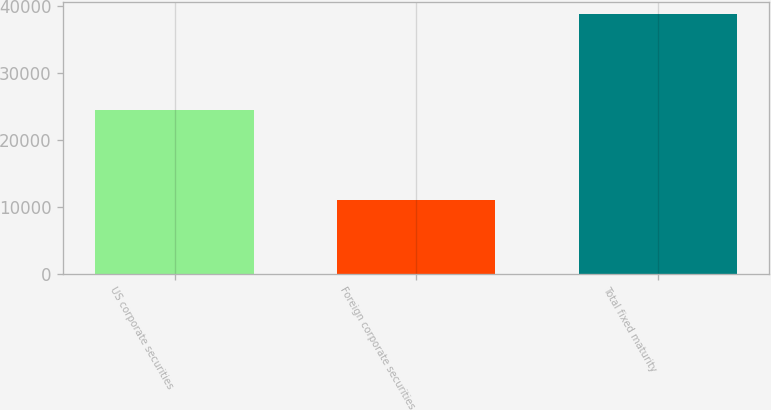<chart> <loc_0><loc_0><loc_500><loc_500><bar_chart><fcel>US corporate securities<fcel>Foreign corporate securities<fcel>Total fixed maturity<nl><fcel>24438<fcel>11039<fcel>38761<nl></chart> 